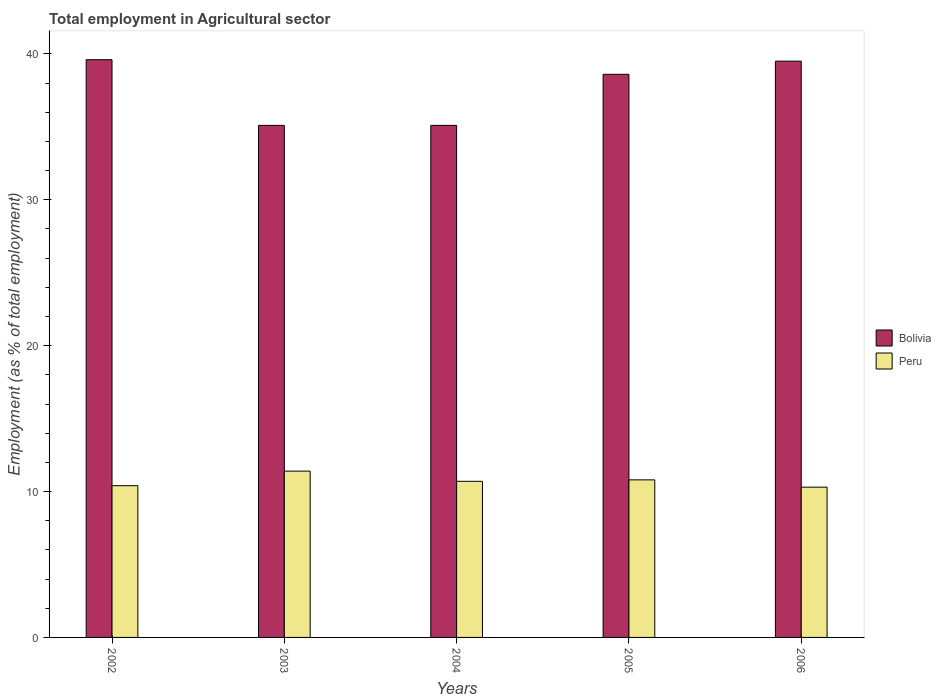How many groups of bars are there?
Your answer should be very brief. 5. Are the number of bars on each tick of the X-axis equal?
Keep it short and to the point. Yes. How many bars are there on the 4th tick from the left?
Offer a very short reply. 2. How many bars are there on the 1st tick from the right?
Offer a terse response. 2. What is the employment in agricultural sector in Bolivia in 2004?
Your answer should be compact. 35.1. Across all years, what is the maximum employment in agricultural sector in Peru?
Provide a succinct answer. 11.4. Across all years, what is the minimum employment in agricultural sector in Bolivia?
Keep it short and to the point. 35.1. In which year was the employment in agricultural sector in Bolivia minimum?
Ensure brevity in your answer.  2003. What is the total employment in agricultural sector in Peru in the graph?
Your answer should be compact. 53.6. What is the difference between the employment in agricultural sector in Bolivia in 2004 and that in 2006?
Offer a very short reply. -4.4. What is the difference between the employment in agricultural sector in Peru in 2005 and the employment in agricultural sector in Bolivia in 2006?
Keep it short and to the point. -28.7. What is the average employment in agricultural sector in Peru per year?
Give a very brief answer. 10.72. In the year 2002, what is the difference between the employment in agricultural sector in Peru and employment in agricultural sector in Bolivia?
Keep it short and to the point. -29.2. In how many years, is the employment in agricultural sector in Bolivia greater than 20 %?
Your answer should be very brief. 5. What is the ratio of the employment in agricultural sector in Bolivia in 2004 to that in 2005?
Your answer should be very brief. 0.91. Is the employment in agricultural sector in Bolivia in 2002 less than that in 2006?
Your answer should be very brief. No. What is the difference between the highest and the second highest employment in agricultural sector in Bolivia?
Keep it short and to the point. 0.1. What is the difference between the highest and the lowest employment in agricultural sector in Peru?
Give a very brief answer. 1.1. How many years are there in the graph?
Provide a short and direct response. 5. Are the values on the major ticks of Y-axis written in scientific E-notation?
Your answer should be compact. No. Does the graph contain any zero values?
Offer a terse response. No. Does the graph contain grids?
Provide a short and direct response. No. How many legend labels are there?
Your answer should be compact. 2. What is the title of the graph?
Offer a very short reply. Total employment in Agricultural sector. What is the label or title of the X-axis?
Offer a very short reply. Years. What is the label or title of the Y-axis?
Offer a terse response. Employment (as % of total employment). What is the Employment (as % of total employment) of Bolivia in 2002?
Offer a terse response. 39.6. What is the Employment (as % of total employment) in Peru in 2002?
Provide a succinct answer. 10.4. What is the Employment (as % of total employment) in Bolivia in 2003?
Provide a short and direct response. 35.1. What is the Employment (as % of total employment) of Peru in 2003?
Keep it short and to the point. 11.4. What is the Employment (as % of total employment) of Bolivia in 2004?
Provide a short and direct response. 35.1. What is the Employment (as % of total employment) in Peru in 2004?
Ensure brevity in your answer.  10.7. What is the Employment (as % of total employment) of Bolivia in 2005?
Ensure brevity in your answer.  38.6. What is the Employment (as % of total employment) of Peru in 2005?
Ensure brevity in your answer.  10.8. What is the Employment (as % of total employment) in Bolivia in 2006?
Make the answer very short. 39.5. What is the Employment (as % of total employment) in Peru in 2006?
Your answer should be compact. 10.3. Across all years, what is the maximum Employment (as % of total employment) of Bolivia?
Make the answer very short. 39.6. Across all years, what is the maximum Employment (as % of total employment) of Peru?
Offer a very short reply. 11.4. Across all years, what is the minimum Employment (as % of total employment) in Bolivia?
Provide a short and direct response. 35.1. Across all years, what is the minimum Employment (as % of total employment) of Peru?
Provide a short and direct response. 10.3. What is the total Employment (as % of total employment) of Bolivia in the graph?
Your response must be concise. 187.9. What is the total Employment (as % of total employment) in Peru in the graph?
Your answer should be very brief. 53.6. What is the difference between the Employment (as % of total employment) in Bolivia in 2002 and that in 2003?
Offer a very short reply. 4.5. What is the difference between the Employment (as % of total employment) in Peru in 2002 and that in 2003?
Keep it short and to the point. -1. What is the difference between the Employment (as % of total employment) of Peru in 2002 and that in 2004?
Offer a very short reply. -0.3. What is the difference between the Employment (as % of total employment) in Bolivia in 2002 and that in 2005?
Your answer should be very brief. 1. What is the difference between the Employment (as % of total employment) in Peru in 2002 and that in 2005?
Provide a short and direct response. -0.4. What is the difference between the Employment (as % of total employment) in Bolivia in 2002 and that in 2006?
Offer a very short reply. 0.1. What is the difference between the Employment (as % of total employment) of Bolivia in 2003 and that in 2005?
Your response must be concise. -3.5. What is the difference between the Employment (as % of total employment) in Bolivia in 2003 and that in 2006?
Ensure brevity in your answer.  -4.4. What is the difference between the Employment (as % of total employment) in Peru in 2003 and that in 2006?
Your response must be concise. 1.1. What is the difference between the Employment (as % of total employment) in Bolivia in 2004 and that in 2005?
Offer a terse response. -3.5. What is the difference between the Employment (as % of total employment) of Bolivia in 2002 and the Employment (as % of total employment) of Peru in 2003?
Ensure brevity in your answer.  28.2. What is the difference between the Employment (as % of total employment) of Bolivia in 2002 and the Employment (as % of total employment) of Peru in 2004?
Your answer should be compact. 28.9. What is the difference between the Employment (as % of total employment) in Bolivia in 2002 and the Employment (as % of total employment) in Peru in 2005?
Provide a short and direct response. 28.8. What is the difference between the Employment (as % of total employment) in Bolivia in 2002 and the Employment (as % of total employment) in Peru in 2006?
Keep it short and to the point. 29.3. What is the difference between the Employment (as % of total employment) of Bolivia in 2003 and the Employment (as % of total employment) of Peru in 2004?
Offer a very short reply. 24.4. What is the difference between the Employment (as % of total employment) in Bolivia in 2003 and the Employment (as % of total employment) in Peru in 2005?
Make the answer very short. 24.3. What is the difference between the Employment (as % of total employment) in Bolivia in 2003 and the Employment (as % of total employment) in Peru in 2006?
Ensure brevity in your answer.  24.8. What is the difference between the Employment (as % of total employment) in Bolivia in 2004 and the Employment (as % of total employment) in Peru in 2005?
Offer a terse response. 24.3. What is the difference between the Employment (as % of total employment) of Bolivia in 2004 and the Employment (as % of total employment) of Peru in 2006?
Your answer should be compact. 24.8. What is the difference between the Employment (as % of total employment) of Bolivia in 2005 and the Employment (as % of total employment) of Peru in 2006?
Provide a succinct answer. 28.3. What is the average Employment (as % of total employment) in Bolivia per year?
Ensure brevity in your answer.  37.58. What is the average Employment (as % of total employment) of Peru per year?
Make the answer very short. 10.72. In the year 2002, what is the difference between the Employment (as % of total employment) of Bolivia and Employment (as % of total employment) of Peru?
Give a very brief answer. 29.2. In the year 2003, what is the difference between the Employment (as % of total employment) of Bolivia and Employment (as % of total employment) of Peru?
Your answer should be very brief. 23.7. In the year 2004, what is the difference between the Employment (as % of total employment) of Bolivia and Employment (as % of total employment) of Peru?
Your answer should be compact. 24.4. In the year 2005, what is the difference between the Employment (as % of total employment) in Bolivia and Employment (as % of total employment) in Peru?
Provide a succinct answer. 27.8. In the year 2006, what is the difference between the Employment (as % of total employment) of Bolivia and Employment (as % of total employment) of Peru?
Your answer should be very brief. 29.2. What is the ratio of the Employment (as % of total employment) of Bolivia in 2002 to that in 2003?
Make the answer very short. 1.13. What is the ratio of the Employment (as % of total employment) in Peru in 2002 to that in 2003?
Offer a very short reply. 0.91. What is the ratio of the Employment (as % of total employment) in Bolivia in 2002 to that in 2004?
Make the answer very short. 1.13. What is the ratio of the Employment (as % of total employment) of Peru in 2002 to that in 2004?
Offer a terse response. 0.97. What is the ratio of the Employment (as % of total employment) of Bolivia in 2002 to that in 2005?
Your response must be concise. 1.03. What is the ratio of the Employment (as % of total employment) of Peru in 2002 to that in 2005?
Your answer should be compact. 0.96. What is the ratio of the Employment (as % of total employment) in Peru in 2002 to that in 2006?
Give a very brief answer. 1.01. What is the ratio of the Employment (as % of total employment) of Peru in 2003 to that in 2004?
Ensure brevity in your answer.  1.07. What is the ratio of the Employment (as % of total employment) of Bolivia in 2003 to that in 2005?
Your response must be concise. 0.91. What is the ratio of the Employment (as % of total employment) in Peru in 2003 to that in 2005?
Ensure brevity in your answer.  1.06. What is the ratio of the Employment (as % of total employment) in Bolivia in 2003 to that in 2006?
Your response must be concise. 0.89. What is the ratio of the Employment (as % of total employment) in Peru in 2003 to that in 2006?
Your answer should be very brief. 1.11. What is the ratio of the Employment (as % of total employment) of Bolivia in 2004 to that in 2005?
Your answer should be compact. 0.91. What is the ratio of the Employment (as % of total employment) of Peru in 2004 to that in 2005?
Provide a succinct answer. 0.99. What is the ratio of the Employment (as % of total employment) in Bolivia in 2004 to that in 2006?
Give a very brief answer. 0.89. What is the ratio of the Employment (as % of total employment) in Peru in 2004 to that in 2006?
Offer a very short reply. 1.04. What is the ratio of the Employment (as % of total employment) in Bolivia in 2005 to that in 2006?
Provide a short and direct response. 0.98. What is the ratio of the Employment (as % of total employment) in Peru in 2005 to that in 2006?
Provide a short and direct response. 1.05. What is the difference between the highest and the second highest Employment (as % of total employment) in Bolivia?
Make the answer very short. 0.1. 